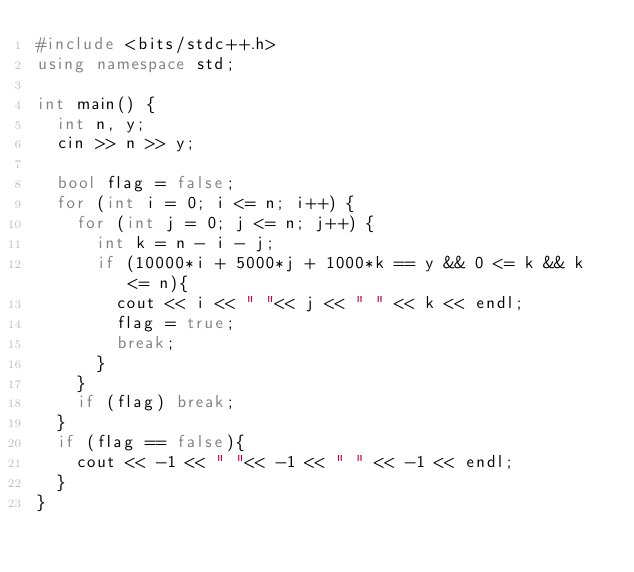Convert code to text. <code><loc_0><loc_0><loc_500><loc_500><_C++_>#include <bits/stdc++.h>
using namespace std;

int main() {
  int n, y;
  cin >> n >> y;

  bool flag = false;
  for (int i = 0; i <= n; i++) {
    for (int j = 0; j <= n; j++) {
      int k = n - i - j;
      if (10000*i + 5000*j + 1000*k == y && 0 <= k && k <= n){
        cout << i << " "<< j << " " << k << endl;
        flag = true;
        break;
      }
    }
    if (flag) break;
  }
  if (flag == false){
    cout << -1 << " "<< -1 << " " << -1 << endl;
  }
}
</code> 